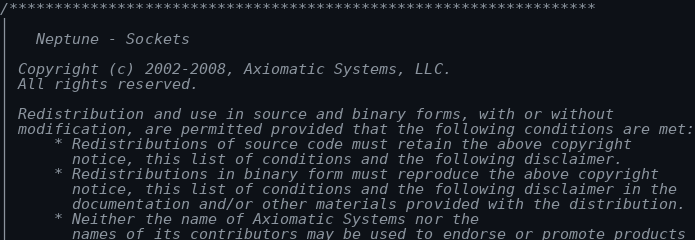Convert code to text. <code><loc_0><loc_0><loc_500><loc_500><_C++_>/*****************************************************************
|
|   Neptune - Sockets
|
| Copyright (c) 2002-2008, Axiomatic Systems, LLC.
| All rights reserved.
|
| Redistribution and use in source and binary forms, with or without
| modification, are permitted provided that the following conditions are met:
|     * Redistributions of source code must retain the above copyright
|       notice, this list of conditions and the following disclaimer.
|     * Redistributions in binary form must reproduce the above copyright
|       notice, this list of conditions and the following disclaimer in the
|       documentation and/or other materials provided with the distribution.
|     * Neither the name of Axiomatic Systems nor the
|       names of its contributors may be used to endorse or promote products</code> 